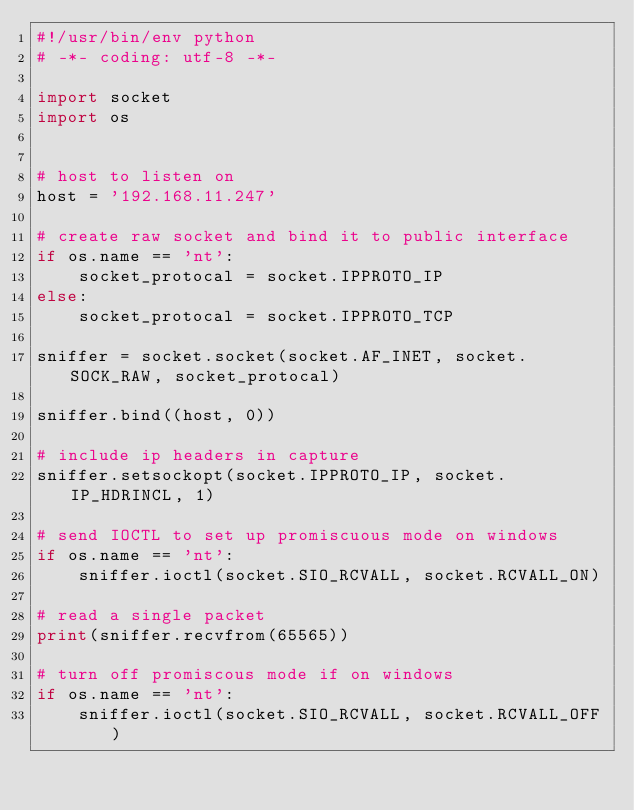<code> <loc_0><loc_0><loc_500><loc_500><_Python_>#!/usr/bin/env python
# -*- coding: utf-8 -*-

import socket
import os


# host to listen on 
host = '192.168.11.247'

# create raw socket and bind it to public interface
if os.name == 'nt':
    socket_protocal = socket.IPPROTO_IP
else:
    socket_protocal = socket.IPPROTO_TCP

sniffer = socket.socket(socket.AF_INET, socket.SOCK_RAW, socket_protocal)

sniffer.bind((host, 0))

# include ip headers in capture
sniffer.setsockopt(socket.IPPROTO_IP, socket.IP_HDRINCL, 1)

# send IOCTL to set up promiscuous mode on windows
if os.name == 'nt':
    sniffer.ioctl(socket.SIO_RCVALL, socket.RCVALL_ON)

# read a single packet
print(sniffer.recvfrom(65565))

# turn off promiscous mode if on windows
if os.name == 'nt':
    sniffer.ioctl(socket.SIO_RCVALL, socket.RCVALL_OFF)
</code> 